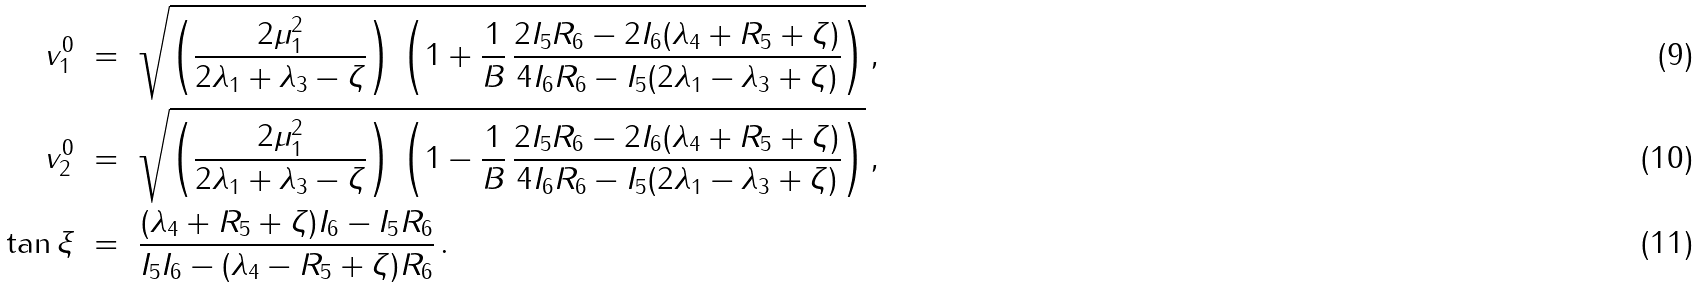Convert formula to latex. <formula><loc_0><loc_0><loc_500><loc_500>v _ { 1 } ^ { 0 } \ & = \ \sqrt { \left ( \frac { 2 \mu _ { 1 } ^ { 2 } } { 2 \lambda _ { 1 } + \lambda _ { 3 } - \zeta } \right ) \, \left ( 1 + \frac { 1 } { B } \, \frac { 2 I _ { 5 } R _ { 6 } - 2 I _ { 6 } ( \lambda _ { 4 } + R _ { 5 } + \zeta ) } { 4 I _ { 6 } R _ { 6 } - I _ { 5 } ( 2 \lambda _ { 1 } - \lambda _ { 3 } + \zeta ) } \right ) } \, , \\ v _ { 2 } ^ { 0 } \ & = \ \sqrt { \left ( \frac { 2 \mu _ { 1 } ^ { 2 } } { 2 \lambda _ { 1 } + \lambda _ { 3 } - \zeta } \right ) \, \left ( 1 - \frac { 1 } { B } \, \frac { 2 I _ { 5 } R _ { 6 } - 2 I _ { 6 } ( \lambda _ { 4 } + R _ { 5 } + \zeta ) } { 4 I _ { 6 } R _ { 6 } - I _ { 5 } ( 2 \lambda _ { 1 } - \lambda _ { 3 } + \zeta ) } \right ) } \, , \\ \tan \xi \ & = \ \frac { ( \lambda _ { 4 } + R _ { 5 } + \zeta ) I _ { 6 } - I _ { 5 } R _ { 6 } } { I _ { 5 } I _ { 6 } - ( \lambda _ { 4 } - R _ { 5 } + \zeta ) R _ { 6 } } \, .</formula> 